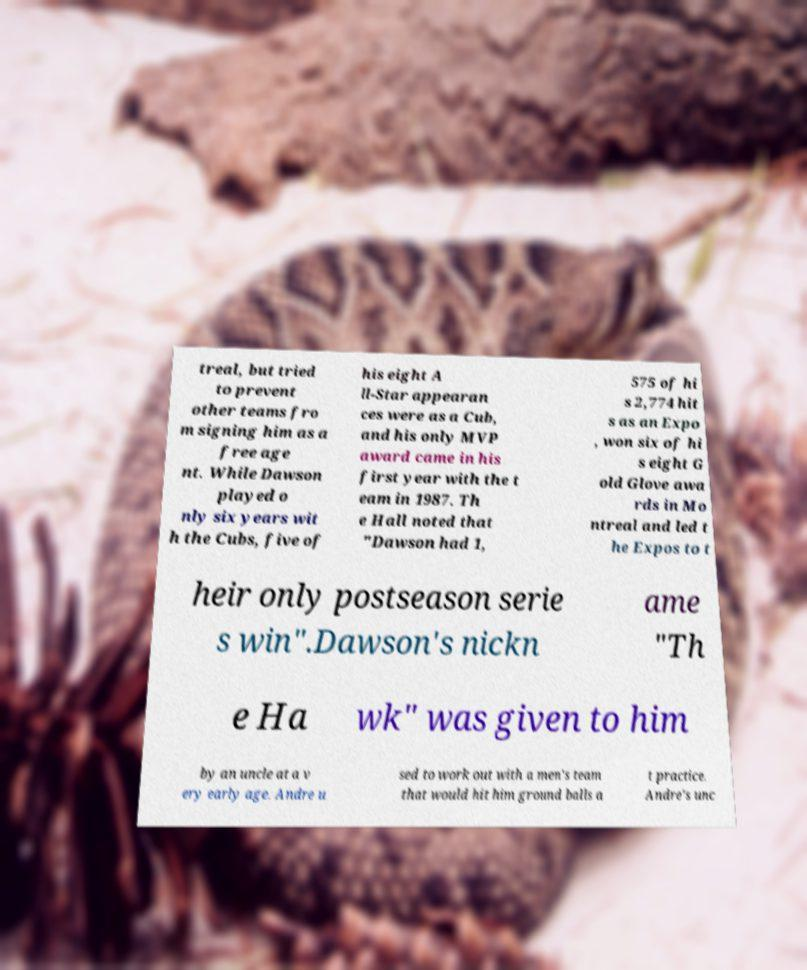I need the written content from this picture converted into text. Can you do that? treal, but tried to prevent other teams fro m signing him as a free age nt. While Dawson played o nly six years wit h the Cubs, five of his eight A ll-Star appearan ces were as a Cub, and his only MVP award came in his first year with the t eam in 1987. Th e Hall noted that "Dawson had 1, 575 of hi s 2,774 hit s as an Expo , won six of hi s eight G old Glove awa rds in Mo ntreal and led t he Expos to t heir only postseason serie s win".Dawson's nickn ame "Th e Ha wk" was given to him by an uncle at a v ery early age. Andre u sed to work out with a men's team that would hit him ground balls a t practice. Andre's unc 